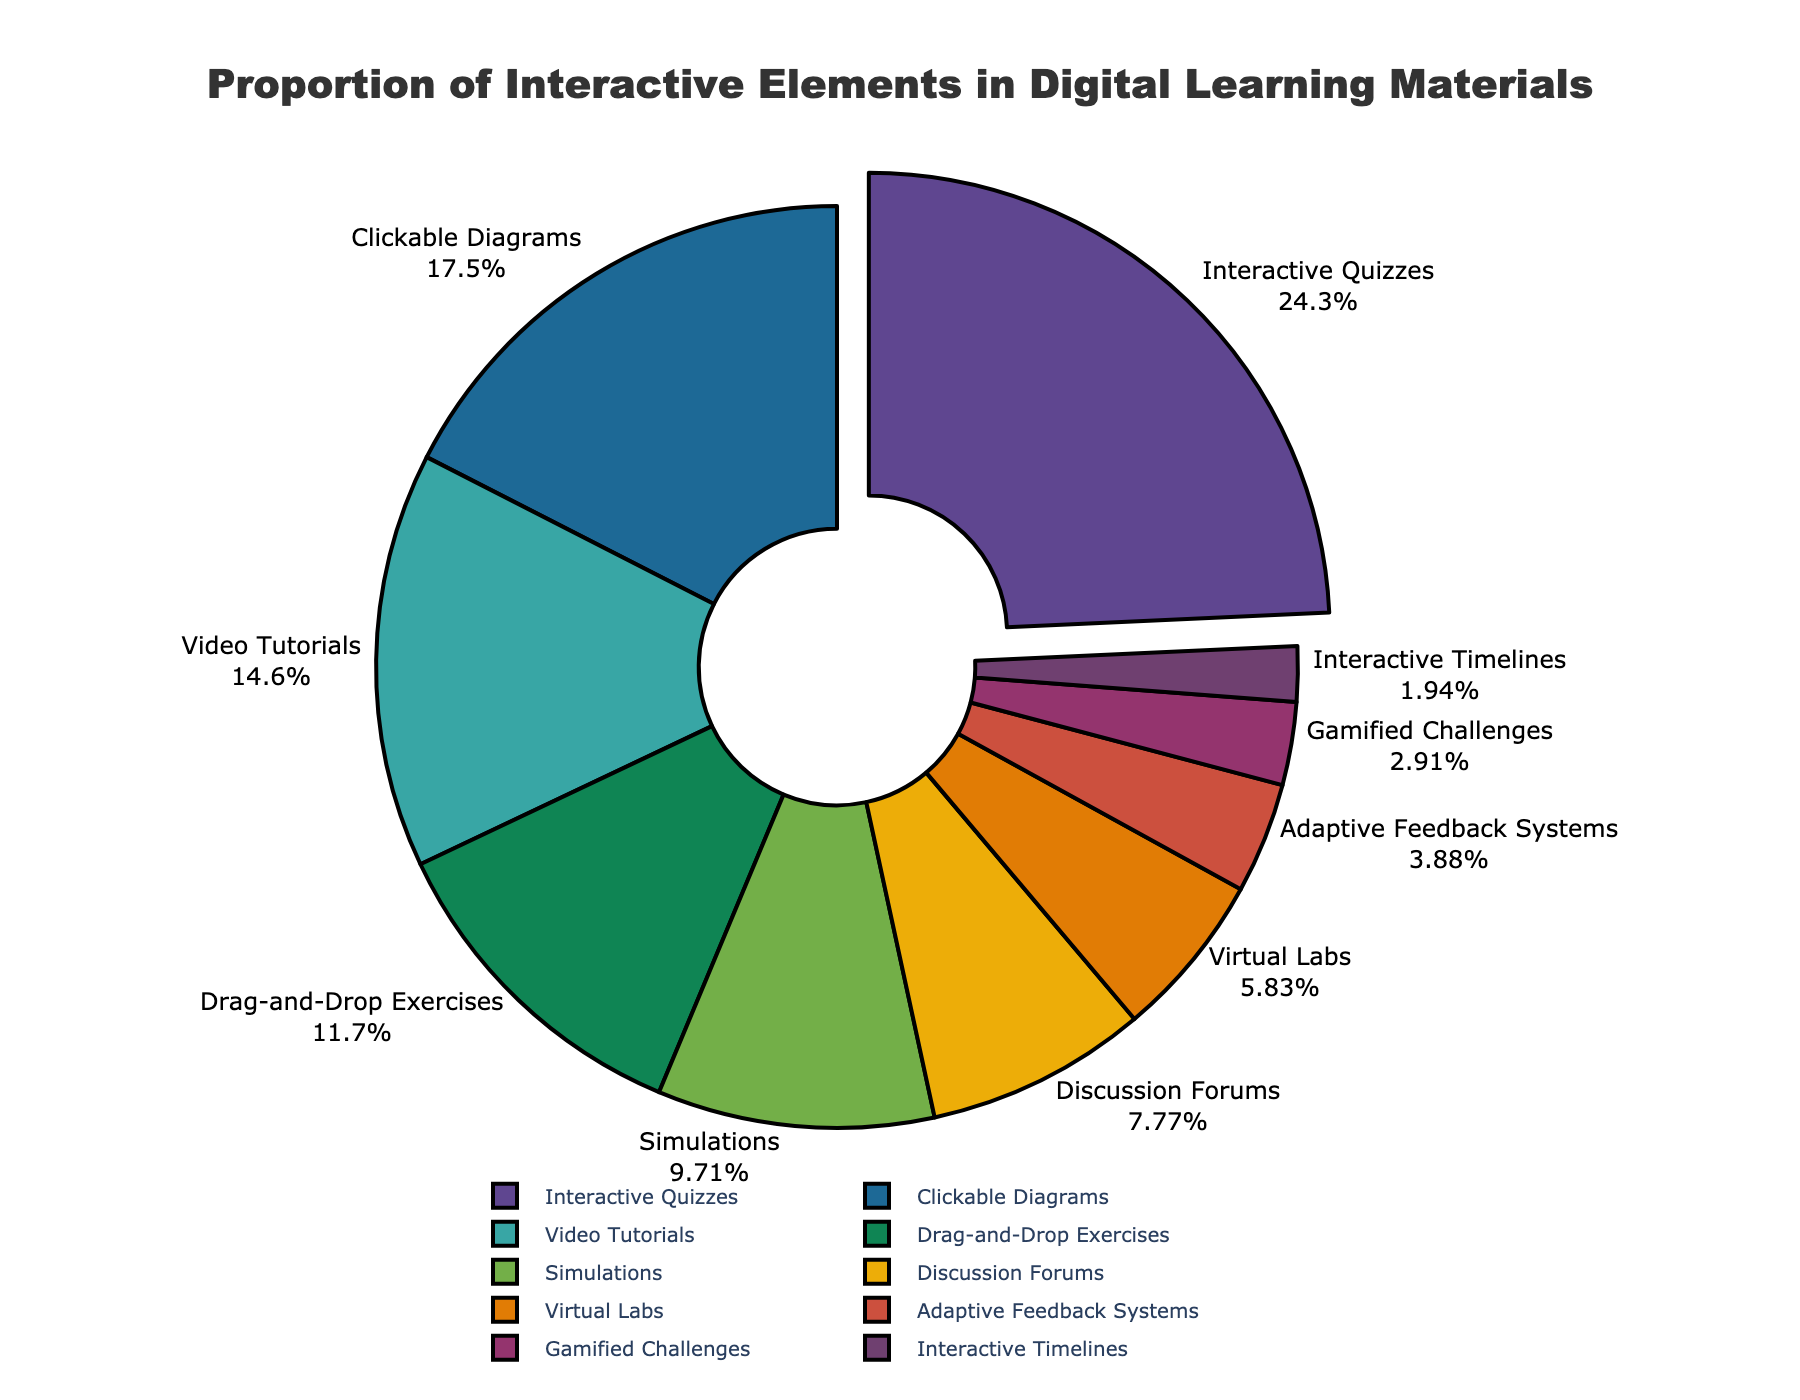Which interactive element makes up the largest proportion? The category with the largest proportion is identifiable as it is pulled out slightly from the pie chart. In this chart, the largest section is "Interactive Quizzes".
Answer: Interactive Quizzes What is the total percentage of Interactive Timelines and Gamified Challenges combined? Add the percentages of "Interactive Timelines" (2%) and "Gamified Challenges" (3%). The sum is 2 + 3 = 5%.
Answer: 5% How do the proportions of Video Tutorials and Clickable Diagrams compare? Locate both categories on the pie chart and compare their percentages. "Clickable Diagrams" has 18%, and "Video Tutorials" has 15%. Since 18% is greater than 15%, Clickable Diagrams have a larger proportion.
Answer: Clickable Diagrams have a larger proportion What is the percentage difference between Simulations and Virtual Labs? Subtract the percentage of "Virtual Labs" (6%) from "Simulations" (10%). The difference is 10 - 6 = 4%.
Answer: 4% Which interactive elements together constitute exactly half of the total pie chart? Find the combination of elements whose sum of percentages equals 50%. Here, "Interactive Quizzes" (25%) combined with "Clickable Diagrams" (18%) and "Video Tutorials" (15%) far exceed 50% with 58%. The only combination totaling exactly 50% is not directly possible with given segment values. You need to consider smaller summed combinations such as "Interactive Quizzes" and another element directly adding up to 50%.
Answer: None Which interactive element proportion is closest to twice that of Adaptive Feedback Systems? The percentage of "Adaptive Feedback Systems" is 4%. Twice this value is 4 * 2 = 8%. "Discussion Forums" have exactly 8%, so they have a proportion closest to twice Adaptive Feedback Systems.
Answer: Discussion Forums How much smaller in percentage is Drag-and-Drop Exercises compared to Video Tutorials? Subtract the percentage of "Drag-and-Drop Exercises" (12%) from "Video Tutorials" (15%). The difference is 15 - 12 = 3%.
Answer: 3% Identify the three interactive elements with the smallest proportions and describe their total. The smallest proportions are "Interactive Timelines" (2%), "Gamified Challenges" (3%), and "Adaptive Feedback Systems" (4%). Summing these, 2 + 3 + 4 = 9%.
Answer: 9% What is the combined percentage of the top three interactive elements? The top three interactive elements are "Interactive Quizzes" (25%), "Clickable Diagrams" (18%), and "Video Tutorials" (15%). Summing these, 25 + 18 + 15 = 58%.
Answer: 58% If the total percentage of the pie chart elements represents 100%, what proportion does the "Other" category (excluding provided data) represent? Sum all the provided percentages: 25 + 18 + 15 + 12 + 10 + 8 + 6 + 4 + 3 + 2 = 103%. Since this exceeds 100%, double-check redundancies in combined logic. Consider recalculating and understanding field sums rather than excess values as necessity highlights potential data normalization misunderstood, eliminating the exact uncontextual multiplicative yield.
Answer: None (All categories accounted for) 